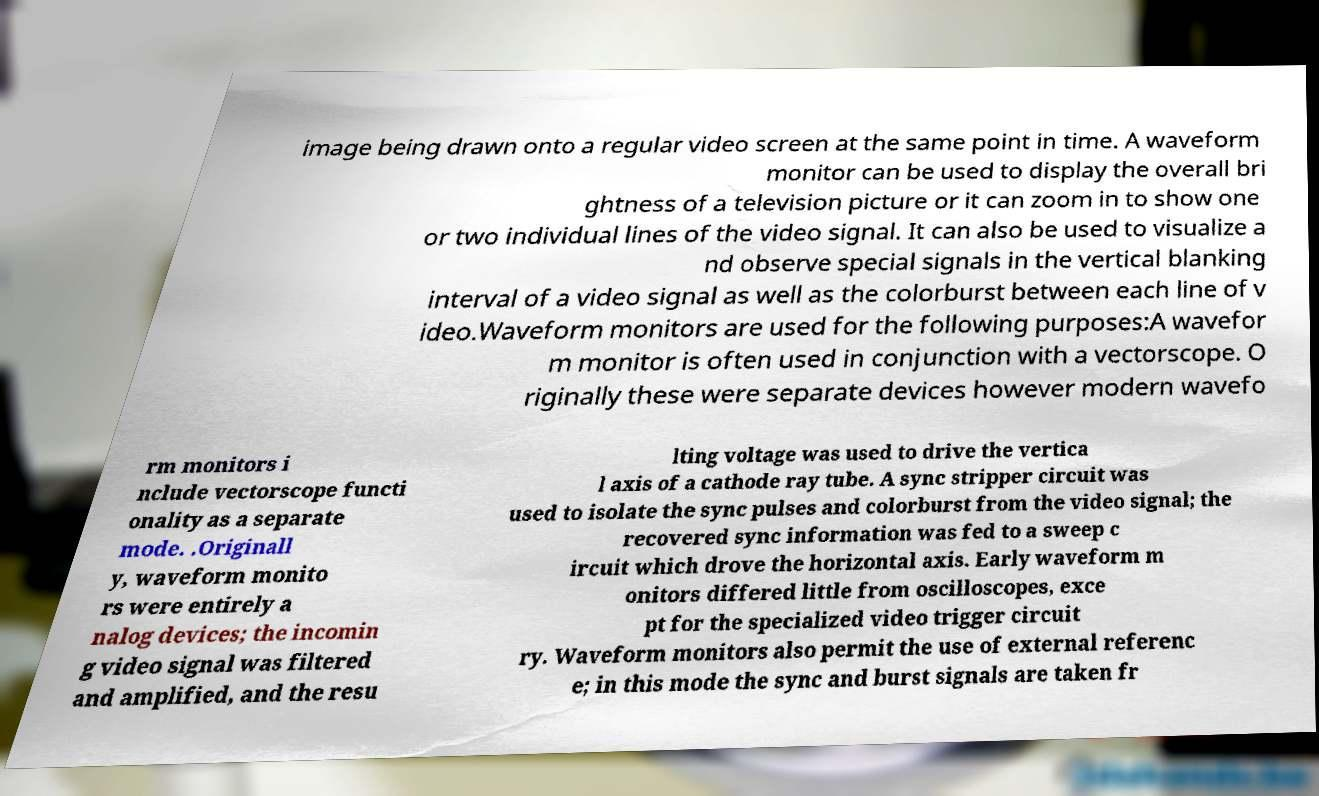Please read and relay the text visible in this image. What does it say? image being drawn onto a regular video screen at the same point in time. A waveform monitor can be used to display the overall bri ghtness of a television picture or it can zoom in to show one or two individual lines of the video signal. It can also be used to visualize a nd observe special signals in the vertical blanking interval of a video signal as well as the colorburst between each line of v ideo.Waveform monitors are used for the following purposes:A wavefor m monitor is often used in conjunction with a vectorscope. O riginally these were separate devices however modern wavefo rm monitors i nclude vectorscope functi onality as a separate mode. .Originall y, waveform monito rs were entirely a nalog devices; the incomin g video signal was filtered and amplified, and the resu lting voltage was used to drive the vertica l axis of a cathode ray tube. A sync stripper circuit was used to isolate the sync pulses and colorburst from the video signal; the recovered sync information was fed to a sweep c ircuit which drove the horizontal axis. Early waveform m onitors differed little from oscilloscopes, exce pt for the specialized video trigger circuit ry. Waveform monitors also permit the use of external referenc e; in this mode the sync and burst signals are taken fr 